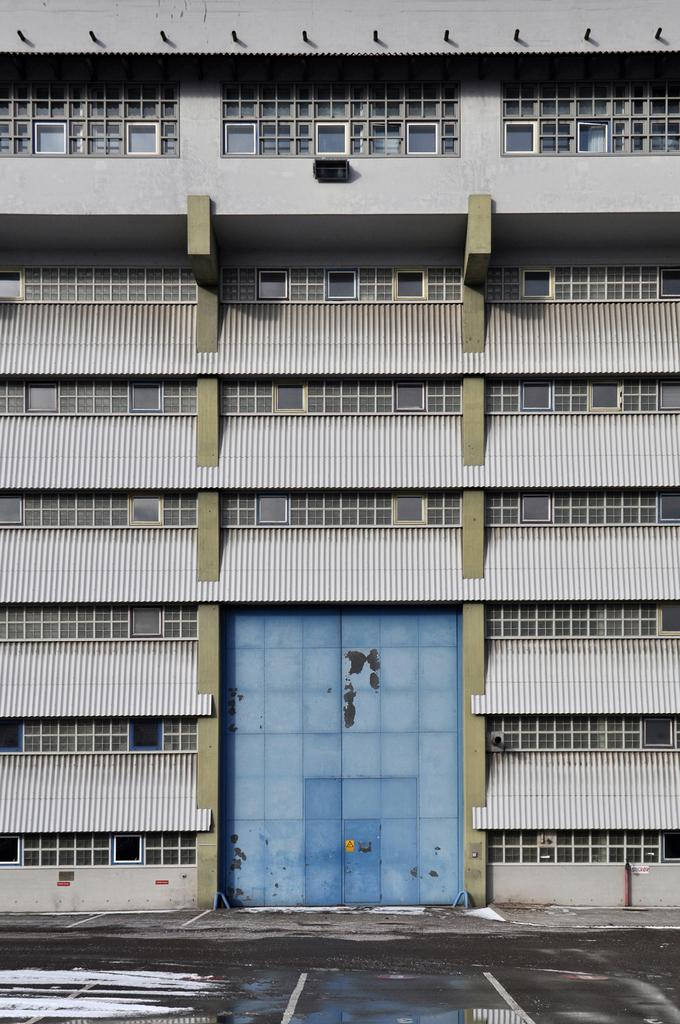What type of structure is present in the image? There is a building in the image. Can you describe the appearance of the building? The building has multiple windows and a blue wall. What is the condition of the ground in the image? There is water on the ground in the image. Can you see a robin perched on the blue wall of the building in the image? There is no robin present in the image. How much salt is visible on the ground in the image? There is no salt visible on the ground in the image. 